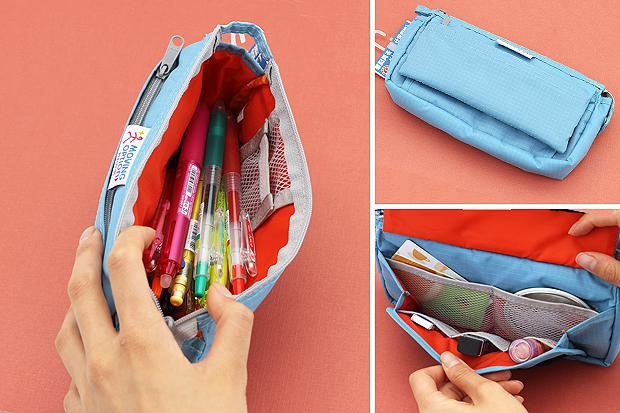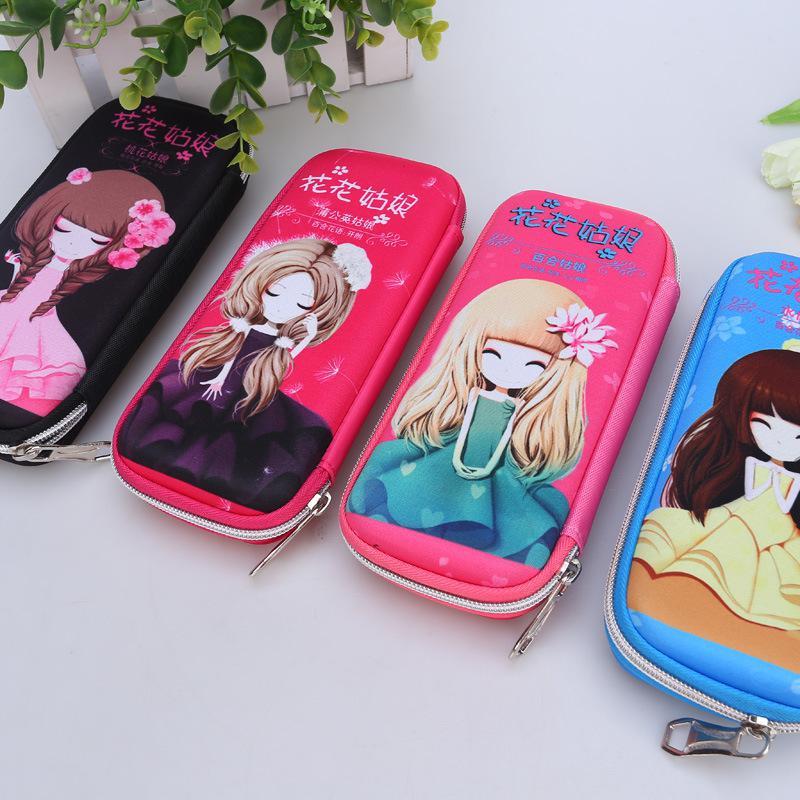The first image is the image on the left, the second image is the image on the right. Examine the images to the left and right. Is the description "An open pencil case contains at least one stick-shaped item with a cartoony face shape on the end." accurate? Answer yes or no. No. The first image is the image on the left, the second image is the image on the right. Given the left and right images, does the statement "A person is holding a pencil case with one hand in the image on the left." hold true? Answer yes or no. Yes. 